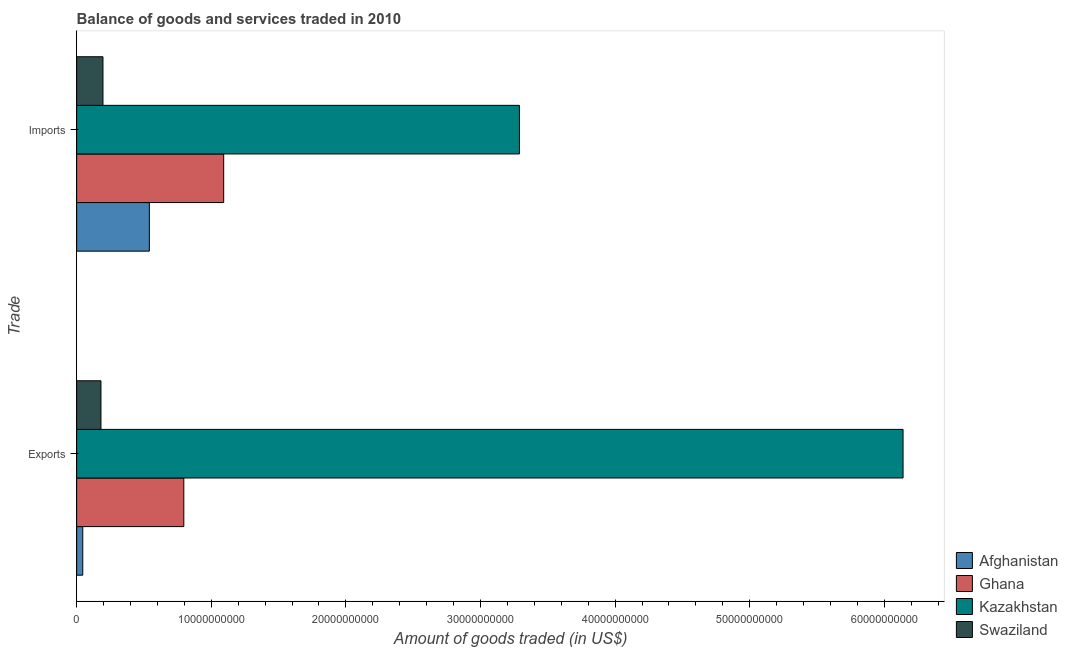How many groups of bars are there?
Provide a succinct answer. 2. Are the number of bars per tick equal to the number of legend labels?
Make the answer very short. Yes. How many bars are there on the 2nd tick from the top?
Provide a succinct answer. 4. How many bars are there on the 2nd tick from the bottom?
Your answer should be compact. 4. What is the label of the 1st group of bars from the top?
Offer a terse response. Imports. What is the amount of goods imported in Swaziland?
Your response must be concise. 1.95e+09. Across all countries, what is the maximum amount of goods imported?
Ensure brevity in your answer.  3.29e+1. Across all countries, what is the minimum amount of goods exported?
Give a very brief answer. 4.53e+08. In which country was the amount of goods imported maximum?
Provide a short and direct response. Kazakhstan. In which country was the amount of goods exported minimum?
Offer a terse response. Afghanistan. What is the total amount of goods exported in the graph?
Offer a terse response. 7.16e+1. What is the difference between the amount of goods imported in Kazakhstan and that in Swaziland?
Make the answer very short. 3.09e+1. What is the difference between the amount of goods exported in Kazakhstan and the amount of goods imported in Ghana?
Offer a terse response. 5.05e+1. What is the average amount of goods imported per country?
Offer a very short reply. 1.28e+1. What is the difference between the amount of goods imported and amount of goods exported in Swaziland?
Make the answer very short. 1.49e+08. What is the ratio of the amount of goods exported in Ghana to that in Afghanistan?
Offer a terse response. 17.56. What does the 2nd bar from the top in Exports represents?
Offer a very short reply. Kazakhstan. What does the 1st bar from the bottom in Exports represents?
Make the answer very short. Afghanistan. How many bars are there?
Offer a terse response. 8. What is the difference between two consecutive major ticks on the X-axis?
Offer a very short reply. 1.00e+1. Are the values on the major ticks of X-axis written in scientific E-notation?
Ensure brevity in your answer.  No. Does the graph contain any zero values?
Ensure brevity in your answer.  No. Does the graph contain grids?
Make the answer very short. No. Where does the legend appear in the graph?
Give a very brief answer. Bottom right. How many legend labels are there?
Provide a short and direct response. 4. How are the legend labels stacked?
Offer a very short reply. Vertical. What is the title of the graph?
Make the answer very short. Balance of goods and services traded in 2010. Does "China" appear as one of the legend labels in the graph?
Make the answer very short. No. What is the label or title of the X-axis?
Ensure brevity in your answer.  Amount of goods traded (in US$). What is the label or title of the Y-axis?
Provide a succinct answer. Trade. What is the Amount of goods traded (in US$) of Afghanistan in Exports?
Ensure brevity in your answer.  4.53e+08. What is the Amount of goods traded (in US$) of Ghana in Exports?
Make the answer very short. 7.96e+09. What is the Amount of goods traded (in US$) of Kazakhstan in Exports?
Give a very brief answer. 6.14e+1. What is the Amount of goods traded (in US$) of Swaziland in Exports?
Offer a very short reply. 1.81e+09. What is the Amount of goods traded (in US$) of Afghanistan in Imports?
Make the answer very short. 5.40e+09. What is the Amount of goods traded (in US$) in Ghana in Imports?
Make the answer very short. 1.09e+1. What is the Amount of goods traded (in US$) of Kazakhstan in Imports?
Offer a terse response. 3.29e+1. What is the Amount of goods traded (in US$) of Swaziland in Imports?
Your answer should be very brief. 1.95e+09. Across all Trade, what is the maximum Amount of goods traded (in US$) in Afghanistan?
Your answer should be compact. 5.40e+09. Across all Trade, what is the maximum Amount of goods traded (in US$) of Ghana?
Offer a very short reply. 1.09e+1. Across all Trade, what is the maximum Amount of goods traded (in US$) of Kazakhstan?
Your answer should be very brief. 6.14e+1. Across all Trade, what is the maximum Amount of goods traded (in US$) of Swaziland?
Provide a succinct answer. 1.95e+09. Across all Trade, what is the minimum Amount of goods traded (in US$) in Afghanistan?
Your answer should be very brief. 4.53e+08. Across all Trade, what is the minimum Amount of goods traded (in US$) of Ghana?
Offer a terse response. 7.96e+09. Across all Trade, what is the minimum Amount of goods traded (in US$) in Kazakhstan?
Ensure brevity in your answer.  3.29e+1. Across all Trade, what is the minimum Amount of goods traded (in US$) of Swaziland?
Ensure brevity in your answer.  1.81e+09. What is the total Amount of goods traded (in US$) of Afghanistan in the graph?
Offer a terse response. 5.85e+09. What is the total Amount of goods traded (in US$) in Ghana in the graph?
Provide a short and direct response. 1.89e+1. What is the total Amount of goods traded (in US$) of Kazakhstan in the graph?
Offer a very short reply. 9.43e+1. What is the total Amount of goods traded (in US$) in Swaziland in the graph?
Offer a terse response. 3.76e+09. What is the difference between the Amount of goods traded (in US$) of Afghanistan in Exports and that in Imports?
Your response must be concise. -4.95e+09. What is the difference between the Amount of goods traded (in US$) in Ghana in Exports and that in Imports?
Provide a short and direct response. -2.96e+09. What is the difference between the Amount of goods traded (in US$) in Kazakhstan in Exports and that in Imports?
Give a very brief answer. 2.85e+1. What is the difference between the Amount of goods traded (in US$) in Swaziland in Exports and that in Imports?
Make the answer very short. -1.49e+08. What is the difference between the Amount of goods traded (in US$) in Afghanistan in Exports and the Amount of goods traded (in US$) in Ghana in Imports?
Offer a terse response. -1.05e+1. What is the difference between the Amount of goods traded (in US$) of Afghanistan in Exports and the Amount of goods traded (in US$) of Kazakhstan in Imports?
Give a very brief answer. -3.24e+1. What is the difference between the Amount of goods traded (in US$) of Afghanistan in Exports and the Amount of goods traded (in US$) of Swaziland in Imports?
Provide a short and direct response. -1.50e+09. What is the difference between the Amount of goods traded (in US$) in Ghana in Exports and the Amount of goods traded (in US$) in Kazakhstan in Imports?
Your answer should be very brief. -2.49e+1. What is the difference between the Amount of goods traded (in US$) of Ghana in Exports and the Amount of goods traded (in US$) of Swaziland in Imports?
Give a very brief answer. 6.01e+09. What is the difference between the Amount of goods traded (in US$) in Kazakhstan in Exports and the Amount of goods traded (in US$) in Swaziland in Imports?
Provide a short and direct response. 5.94e+1. What is the average Amount of goods traded (in US$) of Afghanistan per Trade?
Make the answer very short. 2.93e+09. What is the average Amount of goods traded (in US$) of Ghana per Trade?
Offer a terse response. 9.44e+09. What is the average Amount of goods traded (in US$) of Kazakhstan per Trade?
Give a very brief answer. 4.71e+1. What is the average Amount of goods traded (in US$) in Swaziland per Trade?
Make the answer very short. 1.88e+09. What is the difference between the Amount of goods traded (in US$) of Afghanistan and Amount of goods traded (in US$) of Ghana in Exports?
Make the answer very short. -7.51e+09. What is the difference between the Amount of goods traded (in US$) of Afghanistan and Amount of goods traded (in US$) of Kazakhstan in Exports?
Your response must be concise. -6.09e+1. What is the difference between the Amount of goods traded (in US$) of Afghanistan and Amount of goods traded (in US$) of Swaziland in Exports?
Your answer should be very brief. -1.35e+09. What is the difference between the Amount of goods traded (in US$) in Ghana and Amount of goods traded (in US$) in Kazakhstan in Exports?
Ensure brevity in your answer.  -5.34e+1. What is the difference between the Amount of goods traded (in US$) of Ghana and Amount of goods traded (in US$) of Swaziland in Exports?
Keep it short and to the point. 6.15e+09. What is the difference between the Amount of goods traded (in US$) in Kazakhstan and Amount of goods traded (in US$) in Swaziland in Exports?
Offer a very short reply. 5.96e+1. What is the difference between the Amount of goods traded (in US$) in Afghanistan and Amount of goods traded (in US$) in Ghana in Imports?
Provide a succinct answer. -5.52e+09. What is the difference between the Amount of goods traded (in US$) of Afghanistan and Amount of goods traded (in US$) of Kazakhstan in Imports?
Keep it short and to the point. -2.75e+1. What is the difference between the Amount of goods traded (in US$) in Afghanistan and Amount of goods traded (in US$) in Swaziland in Imports?
Offer a very short reply. 3.45e+09. What is the difference between the Amount of goods traded (in US$) in Ghana and Amount of goods traded (in US$) in Kazakhstan in Imports?
Provide a succinct answer. -2.20e+1. What is the difference between the Amount of goods traded (in US$) in Ghana and Amount of goods traded (in US$) in Swaziland in Imports?
Keep it short and to the point. 8.97e+09. What is the difference between the Amount of goods traded (in US$) of Kazakhstan and Amount of goods traded (in US$) of Swaziland in Imports?
Make the answer very short. 3.09e+1. What is the ratio of the Amount of goods traded (in US$) in Afghanistan in Exports to that in Imports?
Your response must be concise. 0.08. What is the ratio of the Amount of goods traded (in US$) in Ghana in Exports to that in Imports?
Your response must be concise. 0.73. What is the ratio of the Amount of goods traded (in US$) in Kazakhstan in Exports to that in Imports?
Keep it short and to the point. 1.87. What is the ratio of the Amount of goods traded (in US$) of Swaziland in Exports to that in Imports?
Your response must be concise. 0.92. What is the difference between the highest and the second highest Amount of goods traded (in US$) of Afghanistan?
Give a very brief answer. 4.95e+09. What is the difference between the highest and the second highest Amount of goods traded (in US$) of Ghana?
Provide a short and direct response. 2.96e+09. What is the difference between the highest and the second highest Amount of goods traded (in US$) in Kazakhstan?
Offer a terse response. 2.85e+1. What is the difference between the highest and the second highest Amount of goods traded (in US$) in Swaziland?
Give a very brief answer. 1.49e+08. What is the difference between the highest and the lowest Amount of goods traded (in US$) of Afghanistan?
Keep it short and to the point. 4.95e+09. What is the difference between the highest and the lowest Amount of goods traded (in US$) in Ghana?
Make the answer very short. 2.96e+09. What is the difference between the highest and the lowest Amount of goods traded (in US$) in Kazakhstan?
Your answer should be very brief. 2.85e+1. What is the difference between the highest and the lowest Amount of goods traded (in US$) of Swaziland?
Your answer should be very brief. 1.49e+08. 